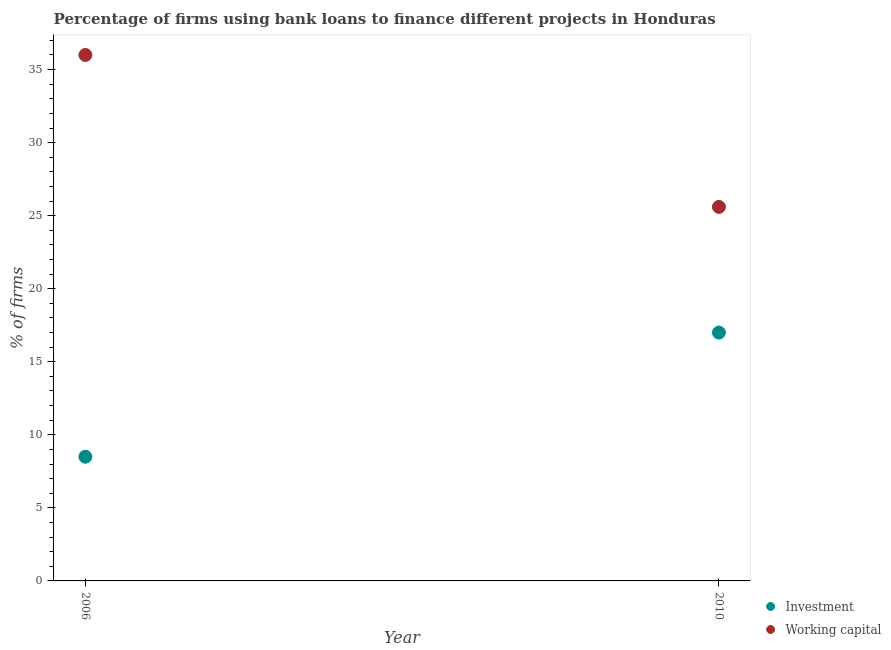How many different coloured dotlines are there?
Your answer should be compact. 2. Is the number of dotlines equal to the number of legend labels?
Provide a short and direct response. Yes. What is the percentage of firms using banks to finance investment in 2010?
Your answer should be very brief. 17. Across all years, what is the maximum percentage of firms using banks to finance investment?
Offer a very short reply. 17. In which year was the percentage of firms using banks to finance working capital maximum?
Provide a succinct answer. 2006. In which year was the percentage of firms using banks to finance investment minimum?
Offer a very short reply. 2006. What is the total percentage of firms using banks to finance working capital in the graph?
Your response must be concise. 61.6. What is the difference between the percentage of firms using banks to finance working capital in 2006 and that in 2010?
Offer a very short reply. 10.4. What is the difference between the percentage of firms using banks to finance investment in 2010 and the percentage of firms using banks to finance working capital in 2006?
Your answer should be very brief. -19. What is the average percentage of firms using banks to finance working capital per year?
Provide a succinct answer. 30.8. In the year 2010, what is the difference between the percentage of firms using banks to finance working capital and percentage of firms using banks to finance investment?
Your response must be concise. 8.6. In how many years, is the percentage of firms using banks to finance working capital greater than 18 %?
Make the answer very short. 2. What is the ratio of the percentage of firms using banks to finance investment in 2006 to that in 2010?
Your response must be concise. 0.5. Is the percentage of firms using banks to finance working capital in 2006 less than that in 2010?
Give a very brief answer. No. In how many years, is the percentage of firms using banks to finance investment greater than the average percentage of firms using banks to finance investment taken over all years?
Your answer should be very brief. 1. Is the percentage of firms using banks to finance working capital strictly greater than the percentage of firms using banks to finance investment over the years?
Your answer should be compact. Yes. Is the percentage of firms using banks to finance working capital strictly less than the percentage of firms using banks to finance investment over the years?
Ensure brevity in your answer.  No. How many dotlines are there?
Ensure brevity in your answer.  2. How many years are there in the graph?
Give a very brief answer. 2. Are the values on the major ticks of Y-axis written in scientific E-notation?
Make the answer very short. No. Where does the legend appear in the graph?
Give a very brief answer. Bottom right. What is the title of the graph?
Provide a succinct answer. Percentage of firms using bank loans to finance different projects in Honduras. Does "Exports" appear as one of the legend labels in the graph?
Keep it short and to the point. No. What is the label or title of the Y-axis?
Give a very brief answer. % of firms. What is the % of firms in Working capital in 2006?
Offer a very short reply. 36. What is the % of firms in Working capital in 2010?
Give a very brief answer. 25.6. Across all years, what is the maximum % of firms in Investment?
Give a very brief answer. 17. Across all years, what is the maximum % of firms of Working capital?
Ensure brevity in your answer.  36. Across all years, what is the minimum % of firms in Working capital?
Provide a succinct answer. 25.6. What is the total % of firms in Working capital in the graph?
Your answer should be compact. 61.6. What is the difference between the % of firms of Investment in 2006 and the % of firms of Working capital in 2010?
Your response must be concise. -17.1. What is the average % of firms of Investment per year?
Ensure brevity in your answer.  12.75. What is the average % of firms in Working capital per year?
Provide a succinct answer. 30.8. In the year 2006, what is the difference between the % of firms in Investment and % of firms in Working capital?
Ensure brevity in your answer.  -27.5. What is the ratio of the % of firms in Working capital in 2006 to that in 2010?
Provide a short and direct response. 1.41. What is the difference between the highest and the second highest % of firms of Investment?
Make the answer very short. 8.5. What is the difference between the highest and the second highest % of firms of Working capital?
Ensure brevity in your answer.  10.4. What is the difference between the highest and the lowest % of firms in Working capital?
Provide a succinct answer. 10.4. 